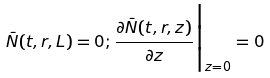<formula> <loc_0><loc_0><loc_500><loc_500>\bar { N } ( t , r , L ) = 0 ; \frac { \partial \bar { N } ( t , r , z ) } { \partial z } { \Big | } _ { z = 0 } = 0</formula> 